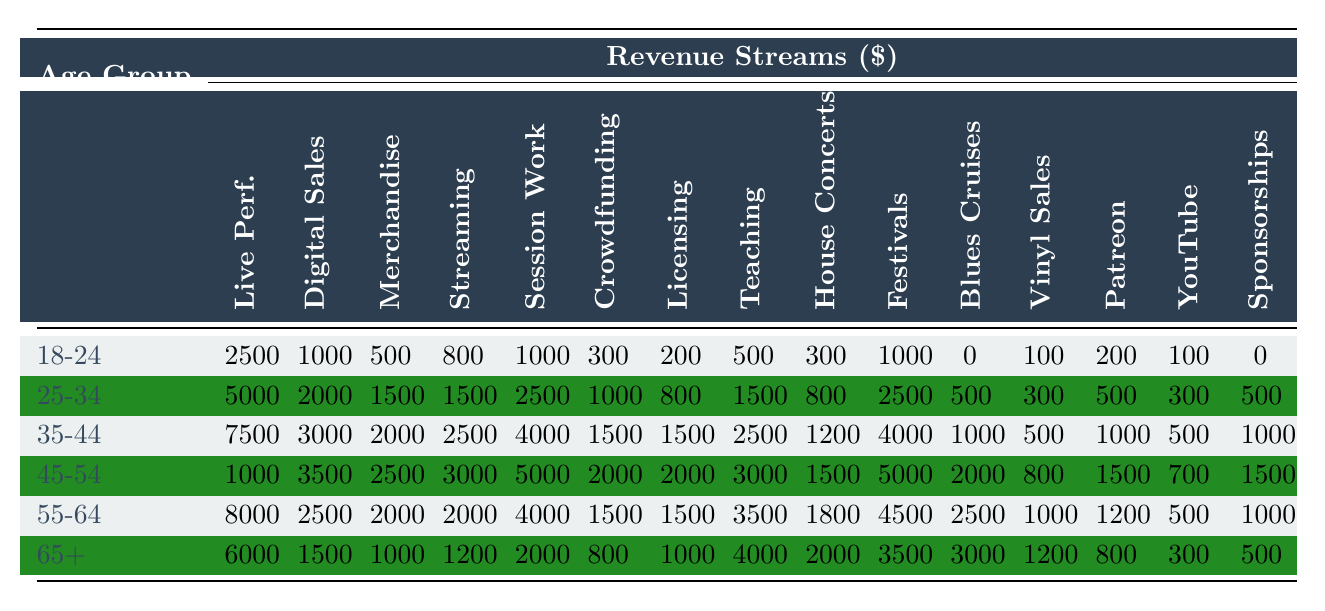What is the revenue from live performances for the 35-44 age group? The table shows that for the 35-44 age group, the revenue from live performances is listed under that age group, which is $7,500.
Answer: $7,500 Which age group has the highest revenue from digital music sales? The table indicates that the 35-44 age group has the highest revenue from digital music sales at $3,000 when compared to all other age groups.
Answer: 35-44 What is the total revenue from merchandise across all age groups? To find the total revenue from merchandise, we add the values: 500 + 1500 + 2000 + 2500 + 2000 + 1000 = 10000.
Answer: $10,000 Is the revenue from streaming royalties for the 55-64 age group greater than that of the 65+ age group? The table shows that the revenue for the 55-64 age group is $2,000, while for the 65+ age group it is $1,200, indicating that $2,000 is greater than $1,200.
Answer: Yes What is the difference in revenue from session work between the 45-54 and the 25-34 age groups? For the 45-54 age group, the revenue from session work is $5,000, and for 25-34 it is $2,500. The difference is $5,000 - $2,500 = $2,500.
Answer: $2,500 Which age group has the highest revenue from teaching/workshops? The table reveals that the 55-64 age group has the highest revenue from teaching/workshops at $3,500, more than any other age group.
Answer: 55-64 Calculate the average revenue from crowdfunding across all age groups. We find the average by adding the crowdfunding values: 300 + 1000 + 1500 + 2000 + 1500 + 800 = 6100; there are 6 age groups, so the average is 6100 / 6 = 1016.67.
Answer: $1,016.67 How much revenue do all age groups combined earn from blues cruises? The revenue from blues cruises for all age groups is summed up: 0 + 500 + 1000 + 2000 + 2500 + 3000 = 10500.
Answer: $10,500 Is the revenue from merchandise higher or lower on average than that from vinyl sales across all age groups? The average revenue from merchandise is 10,000 / 6 = 1666.67, while from vinyl sales it is 3000 / 6 = 500. Since 1666.67 is greater than 500, merchandise is higher on average.
Answer: Higher Which age group has the least revenue from YouTube ad revenue? By checking the table, the 18-24 age group shows the least revenue from YouTube ad revenue at $100.
Answer: 18-24 What percentage of total revenue from festival appearances comes from the 45-54 age group? The total revenue from festival appearances is 10,000; the 45-54 age group contributes 5,000. The percentage is calculated as (5,000 / 10,000) * 100 = 50%.
Answer: 50% How does the revenue from teaching/workshops for the 65+ age group compare to that of the 45-54 age group? The 65+ age group has $4,000 from teaching/workshops, while the 45-54 age group has $3,000. Comparing these amounts shows that $4,000 is greater than $3,000.
Answer: Greater 